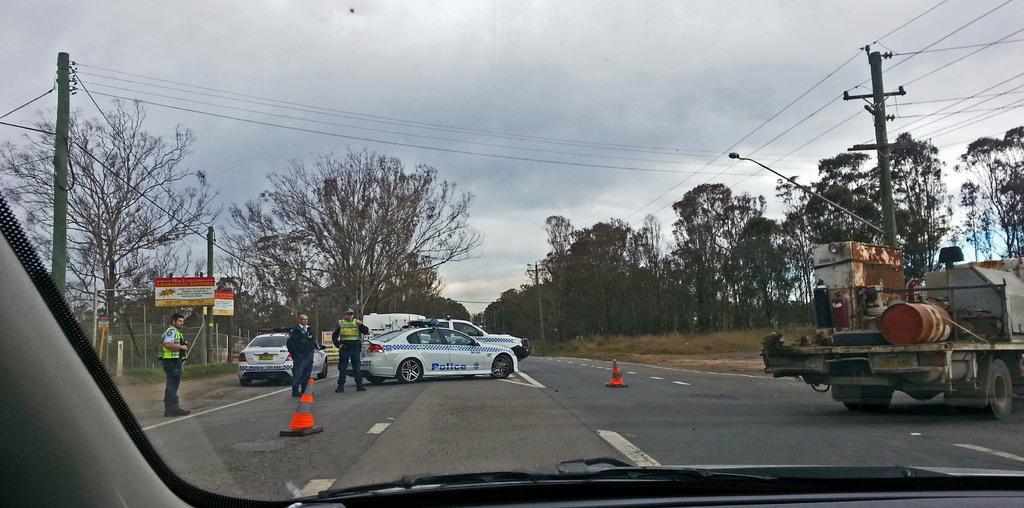How would you summarize this image in a sentence or two? In this image, we can see a glass. Through the glass we can see the outside view. Here we can see three people are standing on the road. Few vehicles, traffic cones, trees, poles, boards, mesh, plants, grass we can see. Background there is a cloudy sky. 